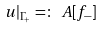<formula> <loc_0><loc_0><loc_500><loc_500>u | _ { \Gamma _ { + } } = \colon \ A [ f _ { - } ]</formula> 